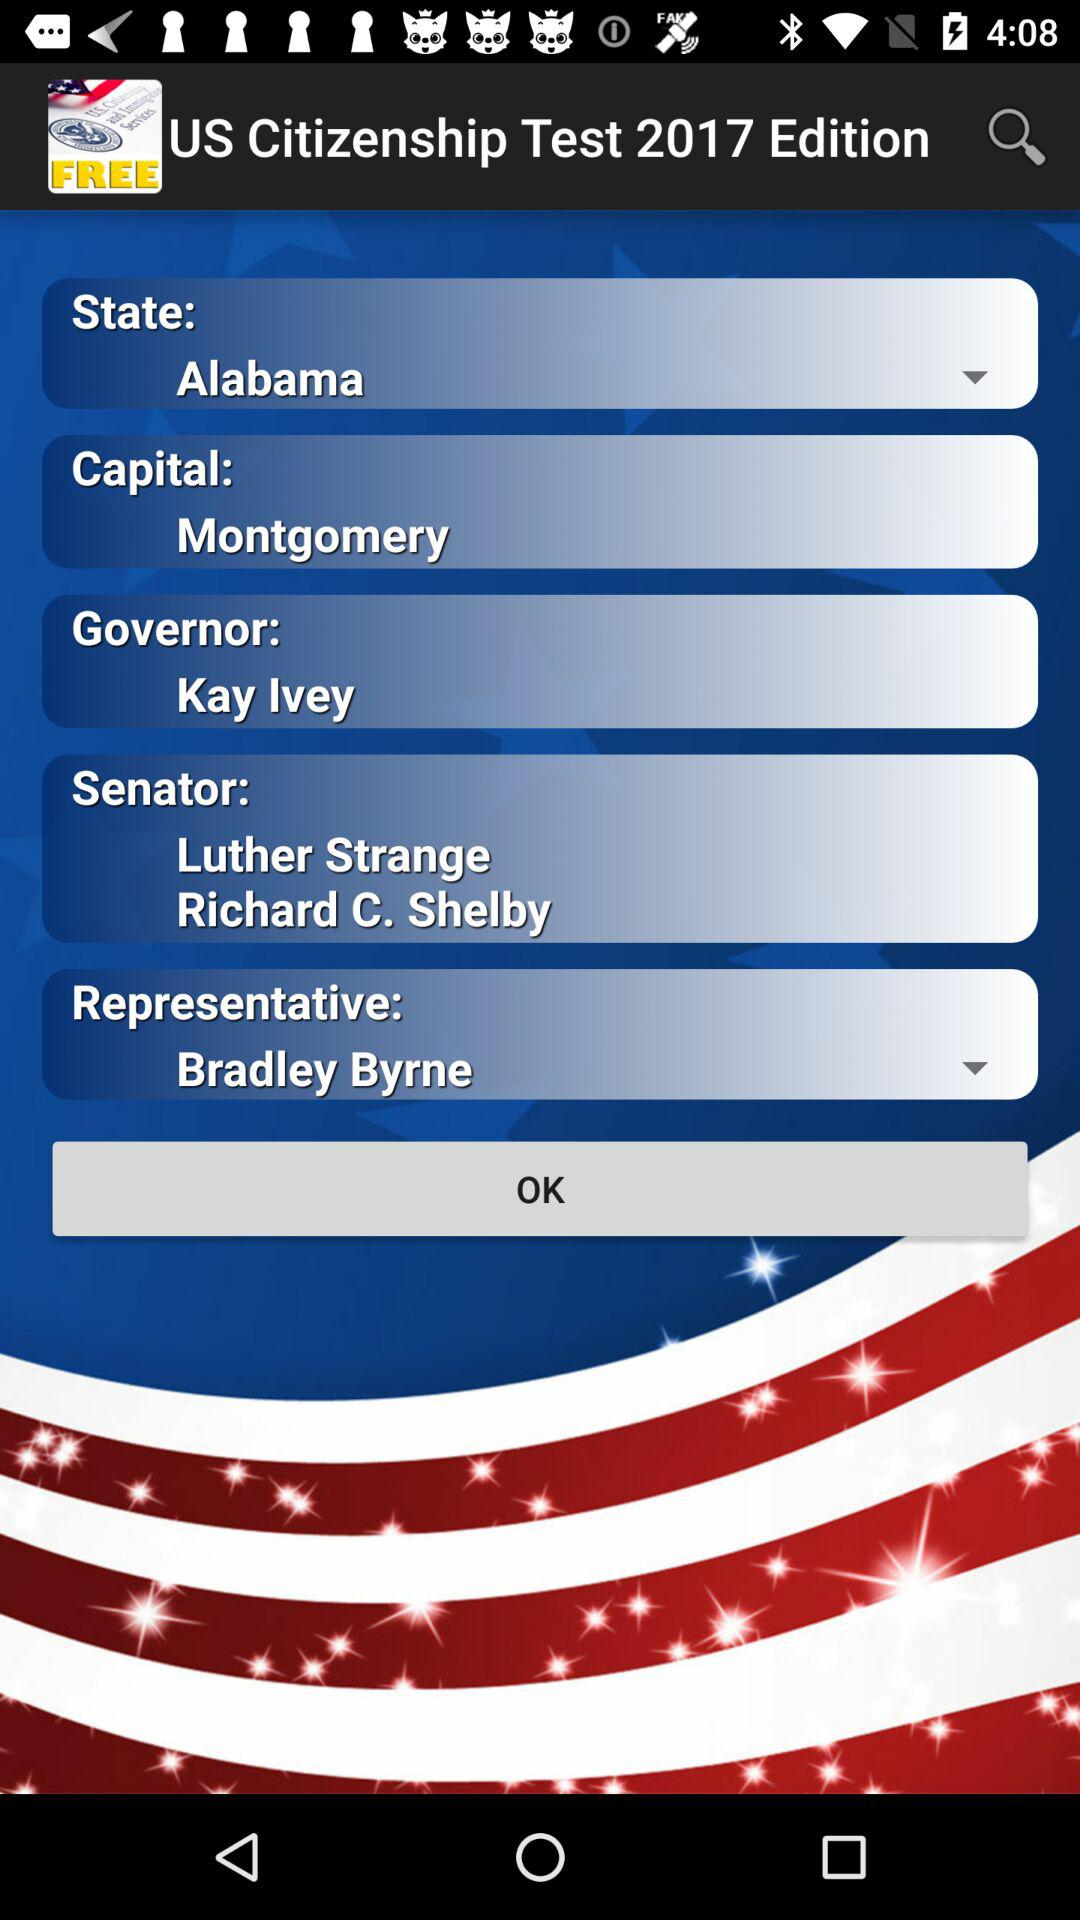Which state is selected? The selected state is Alabama. 